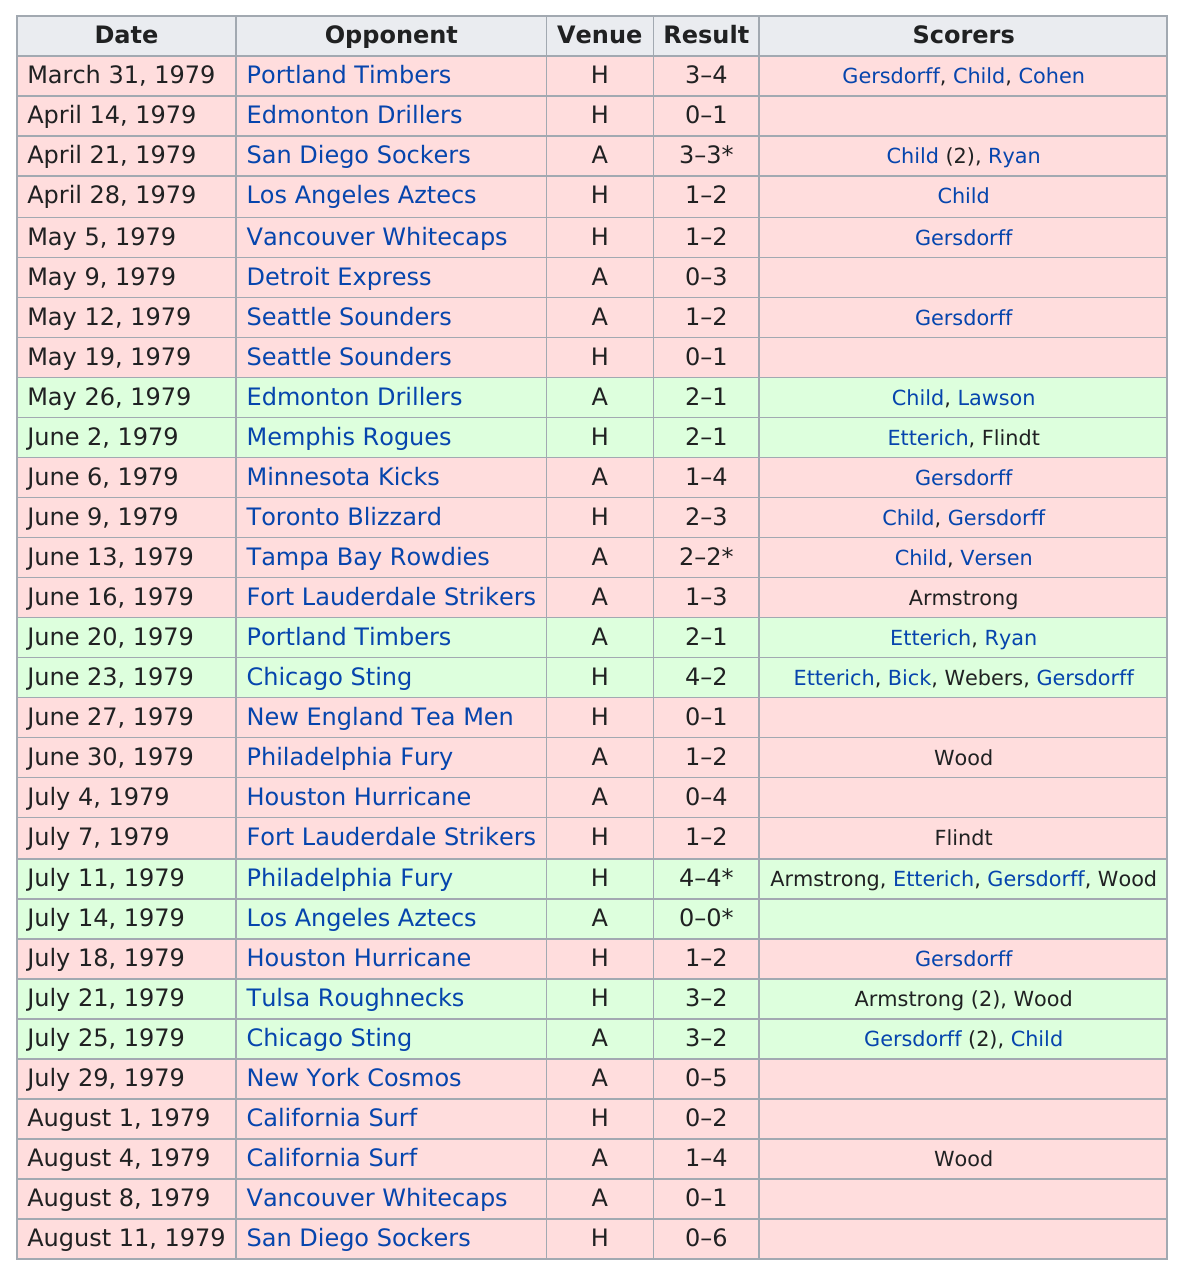Give some essential details in this illustration. During the San Jose Earthquakes' 1979 home opener against the Timbers, a total of three different players scored. After June, a total of 12 games were held. The earthquakes played the Edmonton Drillers after their home opener against the Portland Timbers in the 1979 season. The total number of matches played by the San Jose Earthquakes in the 1979 season was 30. There were two consecutive away games that resulted in a win. 